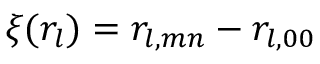Convert formula to latex. <formula><loc_0><loc_0><loc_500><loc_500>\xi ( r _ { l } ) = r _ { l , m n } - r _ { l , 0 0 }</formula> 